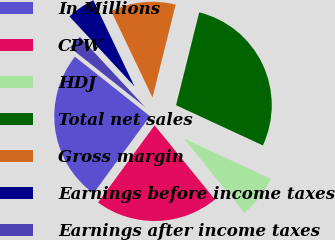Convert chart. <chart><loc_0><loc_0><loc_500><loc_500><pie_chart><fcel>In Millions<fcel>CPW<fcel>HDJ<fcel>Total net sales<fcel>Gross margin<fcel>Earnings before income taxes<fcel>Earnings after income taxes<nl><fcel>25.61%<fcel>20.93%<fcel>7.22%<fcel>28.01%<fcel>10.99%<fcel>4.82%<fcel>2.42%<nl></chart> 